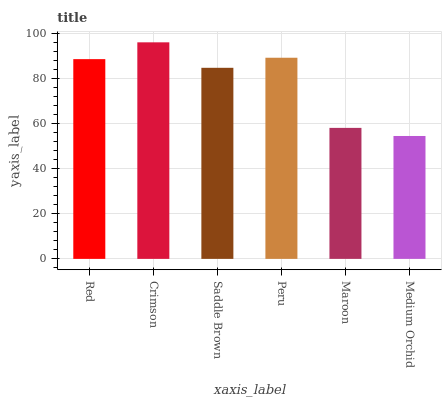Is Saddle Brown the minimum?
Answer yes or no. No. Is Saddle Brown the maximum?
Answer yes or no. No. Is Crimson greater than Saddle Brown?
Answer yes or no. Yes. Is Saddle Brown less than Crimson?
Answer yes or no. Yes. Is Saddle Brown greater than Crimson?
Answer yes or no. No. Is Crimson less than Saddle Brown?
Answer yes or no. No. Is Red the high median?
Answer yes or no. Yes. Is Saddle Brown the low median?
Answer yes or no. Yes. Is Maroon the high median?
Answer yes or no. No. Is Peru the low median?
Answer yes or no. No. 